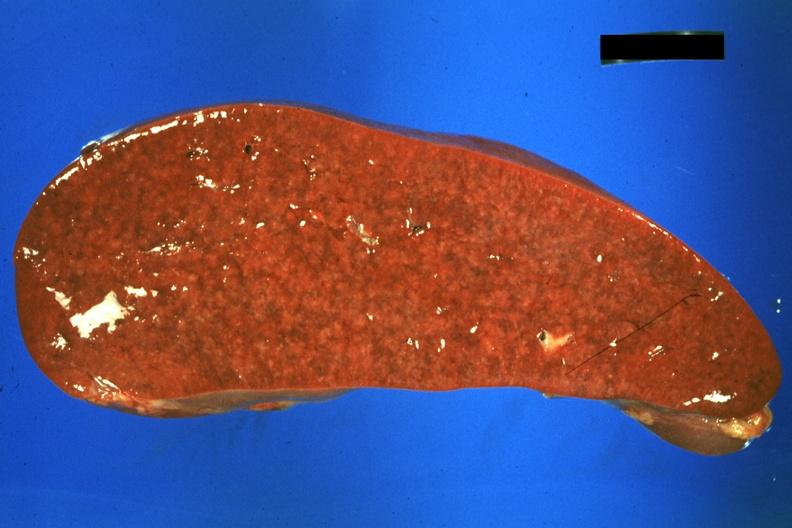what is present?
Answer the question using a single word or phrase. Spleen 